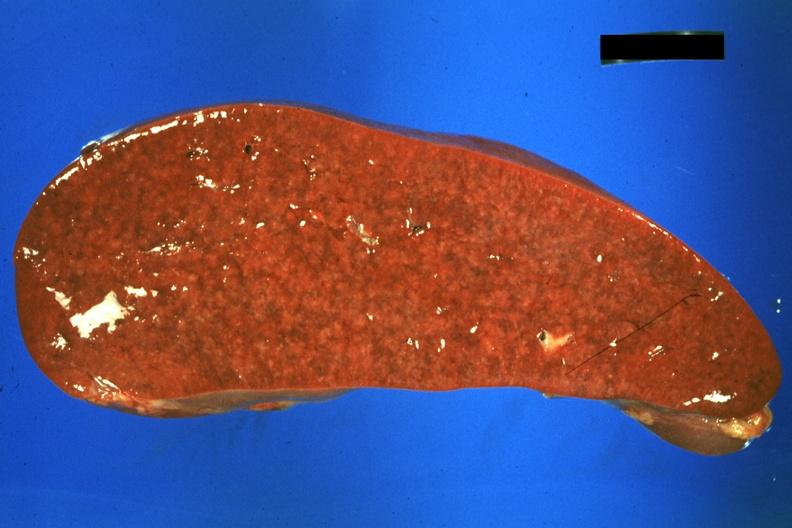what is present?
Answer the question using a single word or phrase. Spleen 